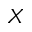Convert formula to latex. <formula><loc_0><loc_0><loc_500><loc_500>_ { X }</formula> 